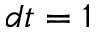Convert formula to latex. <formula><loc_0><loc_0><loc_500><loc_500>d t = 1</formula> 